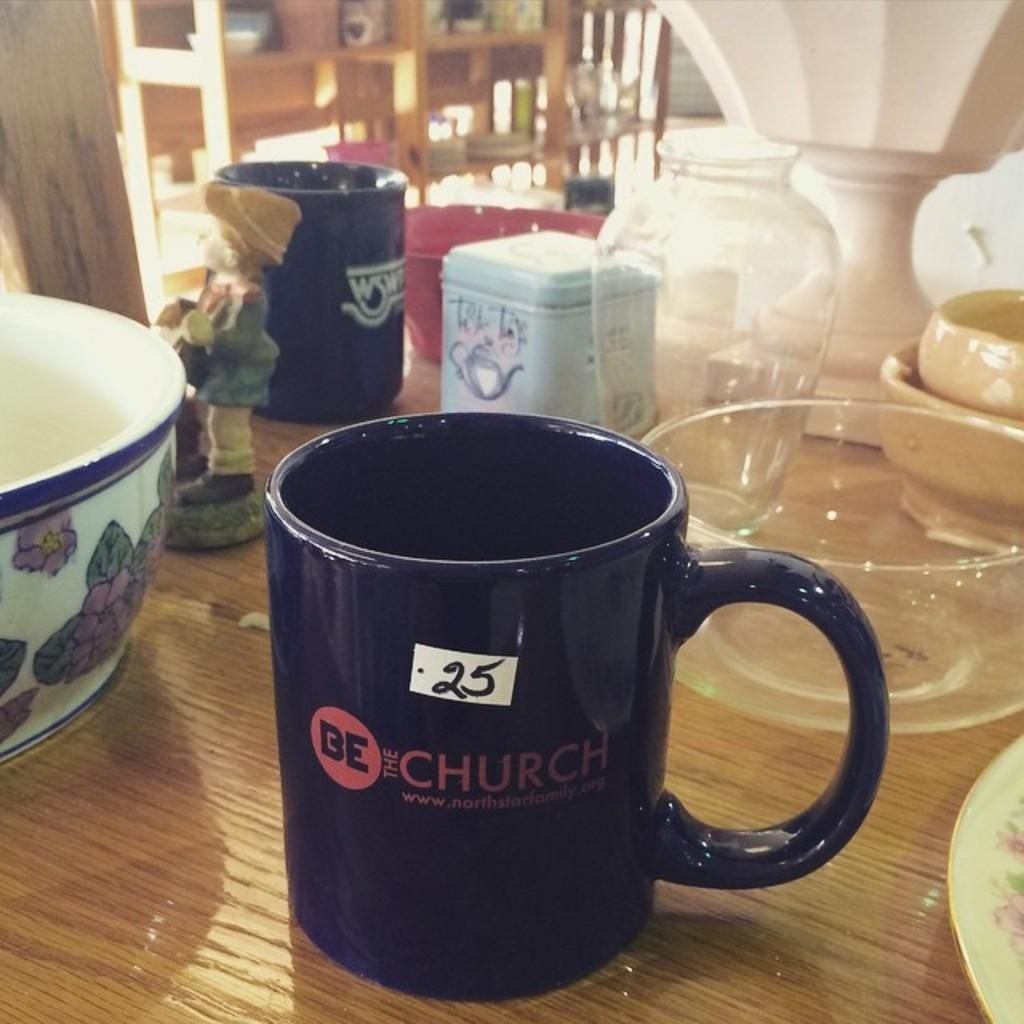<image>
Share a concise interpretation of the image provided. A mug with the slogan "Be the Church" is marked 25 cents at a sale. 